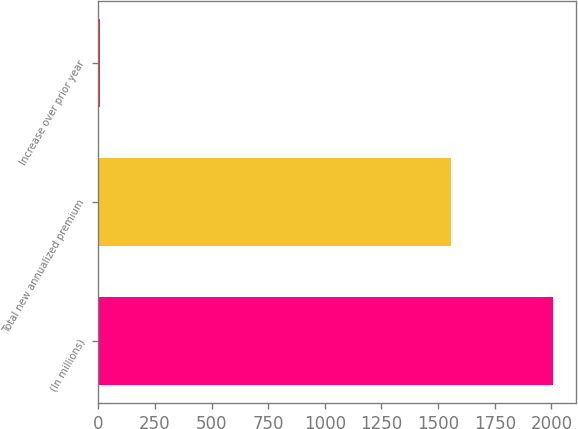Convert chart to OTSL. <chart><loc_0><loc_0><loc_500><loc_500><bar_chart><fcel>(In millions)<fcel>Total new annualized premium<fcel>Increase over prior year<nl><fcel>2007<fcel>1558<fcel>9.5<nl></chart> 